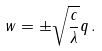Convert formula to latex. <formula><loc_0><loc_0><loc_500><loc_500>w = \pm \sqrt { \frac { c } \lambda } q \, .</formula> 